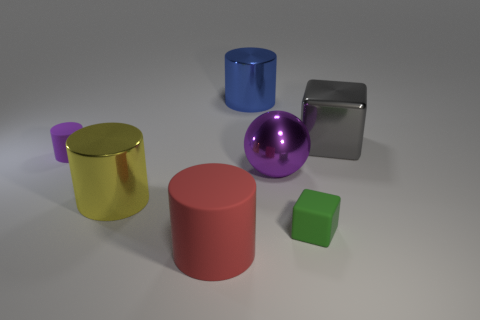Subtract all red cylinders. How many cylinders are left? 3 Subtract 1 cylinders. How many cylinders are left? 3 Subtract all big blue shiny cylinders. How many cylinders are left? 3 Subtract all cyan cylinders. Subtract all cyan balls. How many cylinders are left? 4 Add 3 gray shiny things. How many objects exist? 10 Subtract all spheres. How many objects are left? 6 Add 5 small green rubber things. How many small green rubber things are left? 6 Add 4 blue cubes. How many blue cubes exist? 4 Subtract 0 gray spheres. How many objects are left? 7 Subtract all cyan cylinders. Subtract all small green matte cubes. How many objects are left? 6 